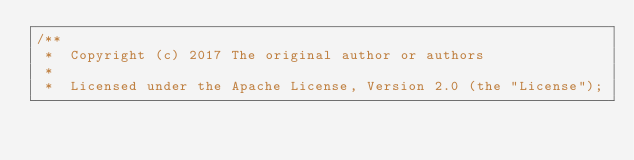Convert code to text. <code><loc_0><loc_0><loc_500><loc_500><_Java_>/** 
 *  Copyright (c) 2017 The original author or authors
 *
 *  Licensed under the Apache License, Version 2.0 (the "License");</code> 